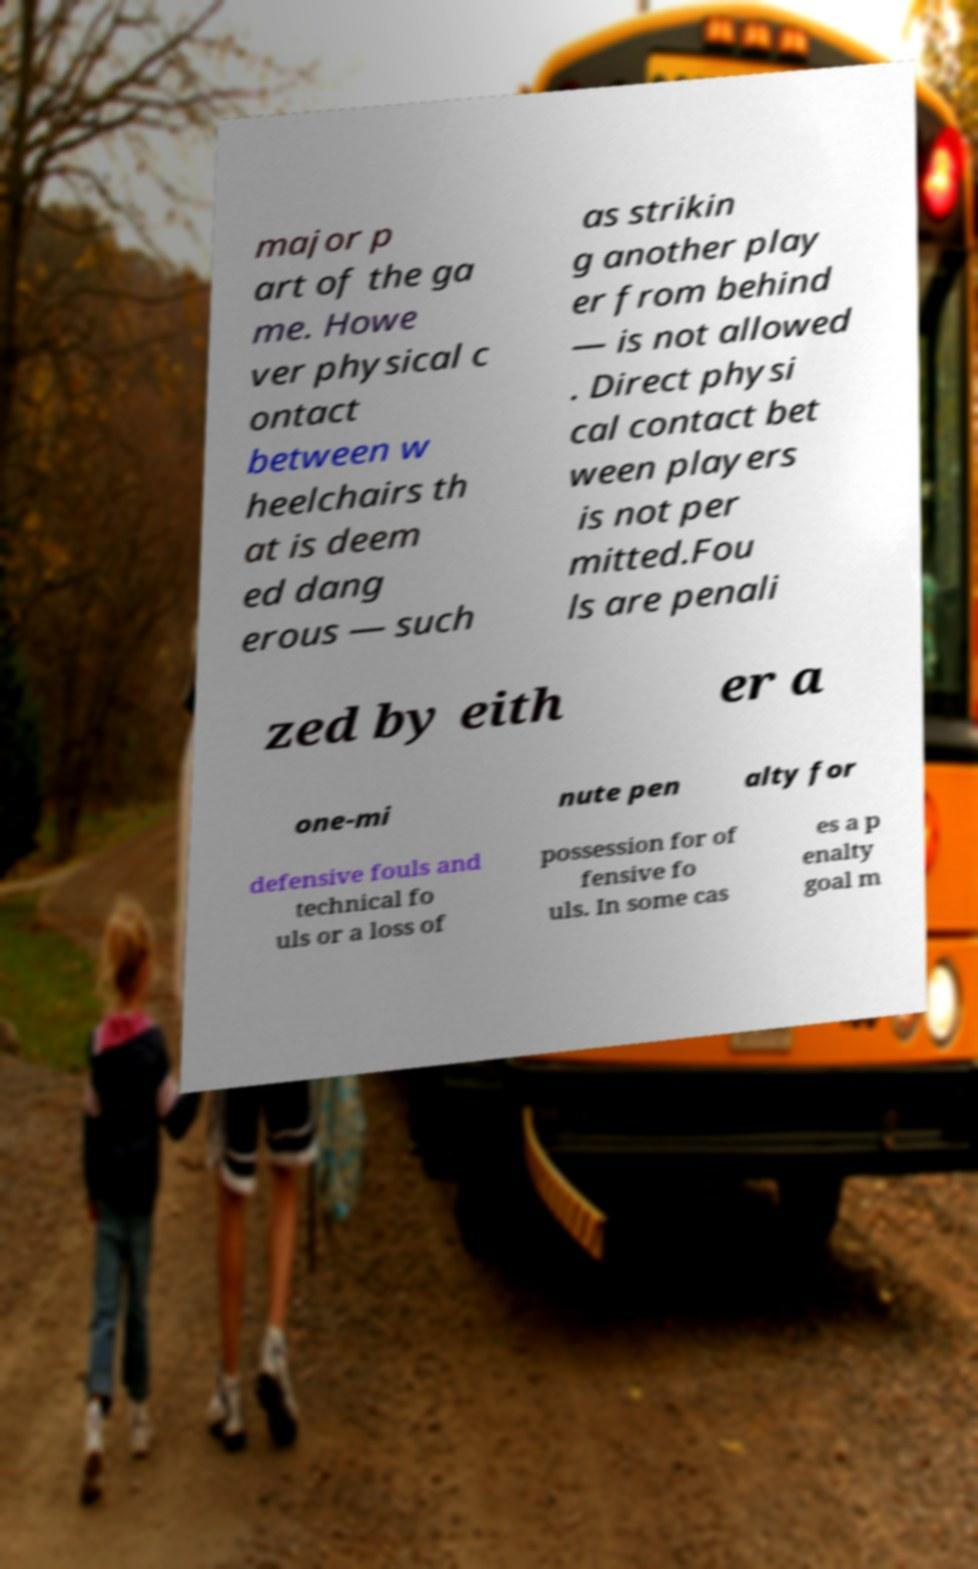Could you extract and type out the text from this image? major p art of the ga me. Howe ver physical c ontact between w heelchairs th at is deem ed dang erous — such as strikin g another play er from behind — is not allowed . Direct physi cal contact bet ween players is not per mitted.Fou ls are penali zed by eith er a one-mi nute pen alty for defensive fouls and technical fo uls or a loss of possession for of fensive fo uls. In some cas es a p enalty goal m 